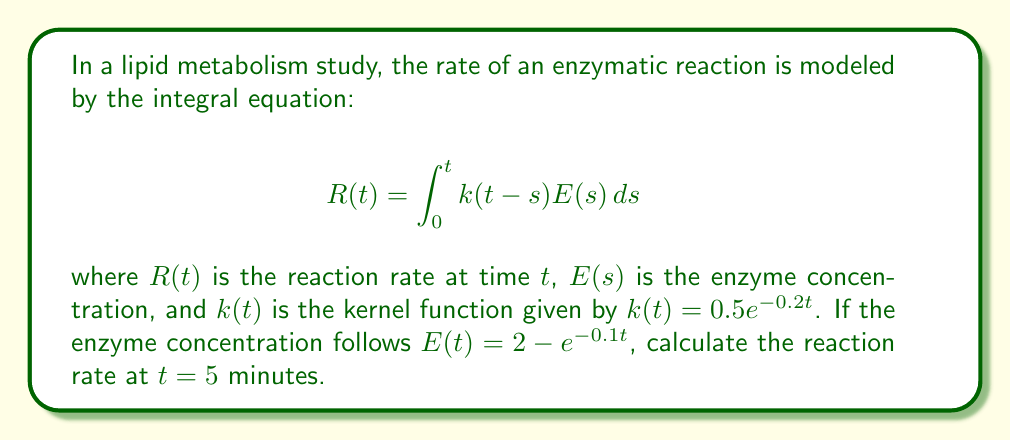Help me with this question. To solve this problem, we'll follow these steps:

1) First, we need to substitute the given functions into the integral equation:

   $$R(5) = \int_0^5 0.5e^{-0.2(5-s)}(2 - e^{-0.1s})ds$$

2) Let's expand the integrand:

   $$R(5) = \int_0^5 (e^{-1+0.2s} - 0.5e^{-1+0.2s-0.1s})ds$$

3) Simplify:

   $$R(5) = \int_0^5 (e^{-1+0.2s} - 0.5e^{-1+0.1s})ds$$

4) Now, we can integrate each term separately:

   $$R(5) = \left[\frac{1}{0.2}e^{-1+0.2s} - \frac{0.5}{0.1}e^{-1+0.1s}\right]_0^5$$

5) Evaluate the integral at the limits:

   $$R(5) = \left(\frac{1}{0.2}e^{-1+1} - \frac{0.5}{0.1}e^{-1+0.5}\right) - \left(\frac{1}{0.2}e^{-1} - \frac{0.5}{0.1}e^{-1}\right)$$

6) Simplify:

   $$R(5) = 5 - 5e^{-0.5} - 5e^{-1} + 5e^{-1}$$

7) Cancel out terms and calculate:

   $$R(5) = 5 - 5e^{-0.5} \approx 1.9648$$

Therefore, the reaction rate at $t = 5$ minutes is approximately 1.9648 units/minute.
Answer: 1.9648 units/minute 